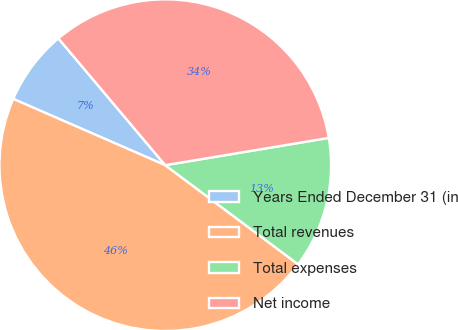Convert chart. <chart><loc_0><loc_0><loc_500><loc_500><pie_chart><fcel>Years Ended December 31 (in<fcel>Total revenues<fcel>Total expenses<fcel>Net income<nl><fcel>7.31%<fcel>46.34%<fcel>12.83%<fcel>33.51%<nl></chart> 